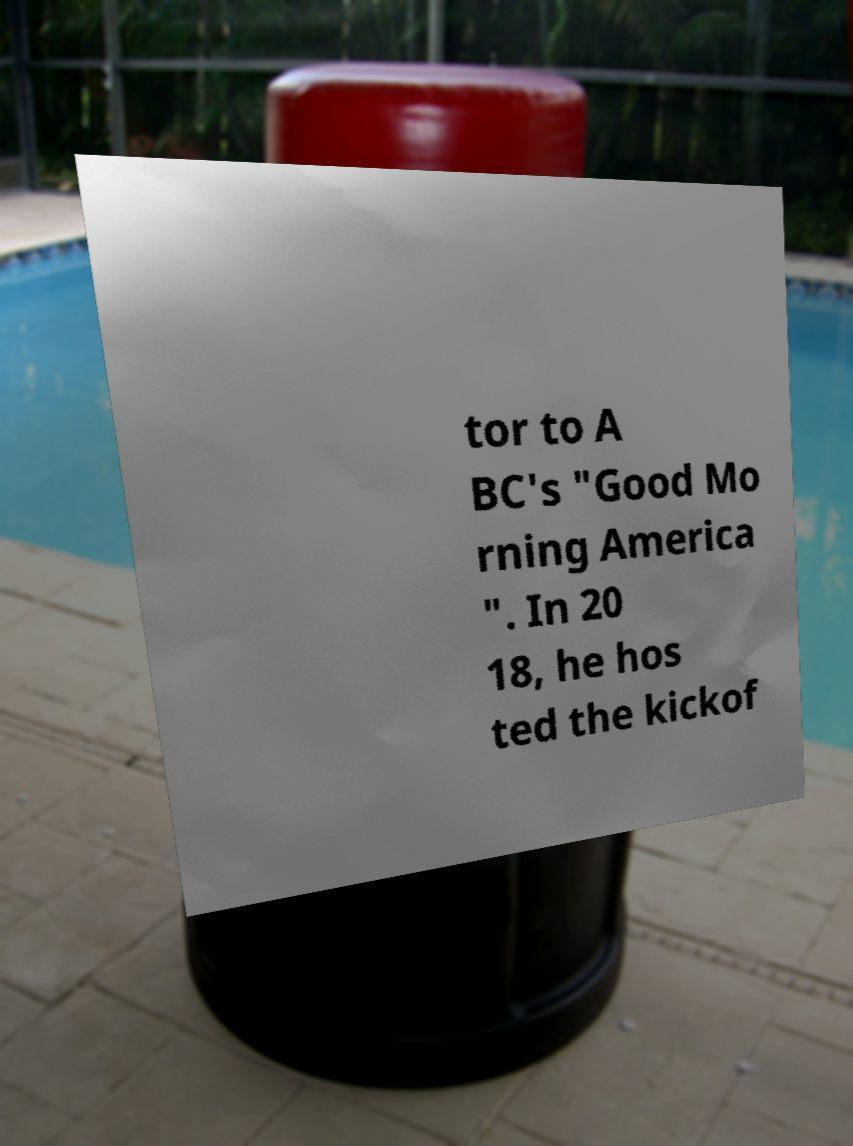Could you extract and type out the text from this image? tor to A BC's "Good Mo rning America ". In 20 18, he hos ted the kickof 